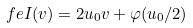Convert formula to latex. <formula><loc_0><loc_0><loc_500><loc_500>\ f e I ( v ) = 2 u _ { 0 } v + \varphi ( u _ { 0 } / 2 )</formula> 